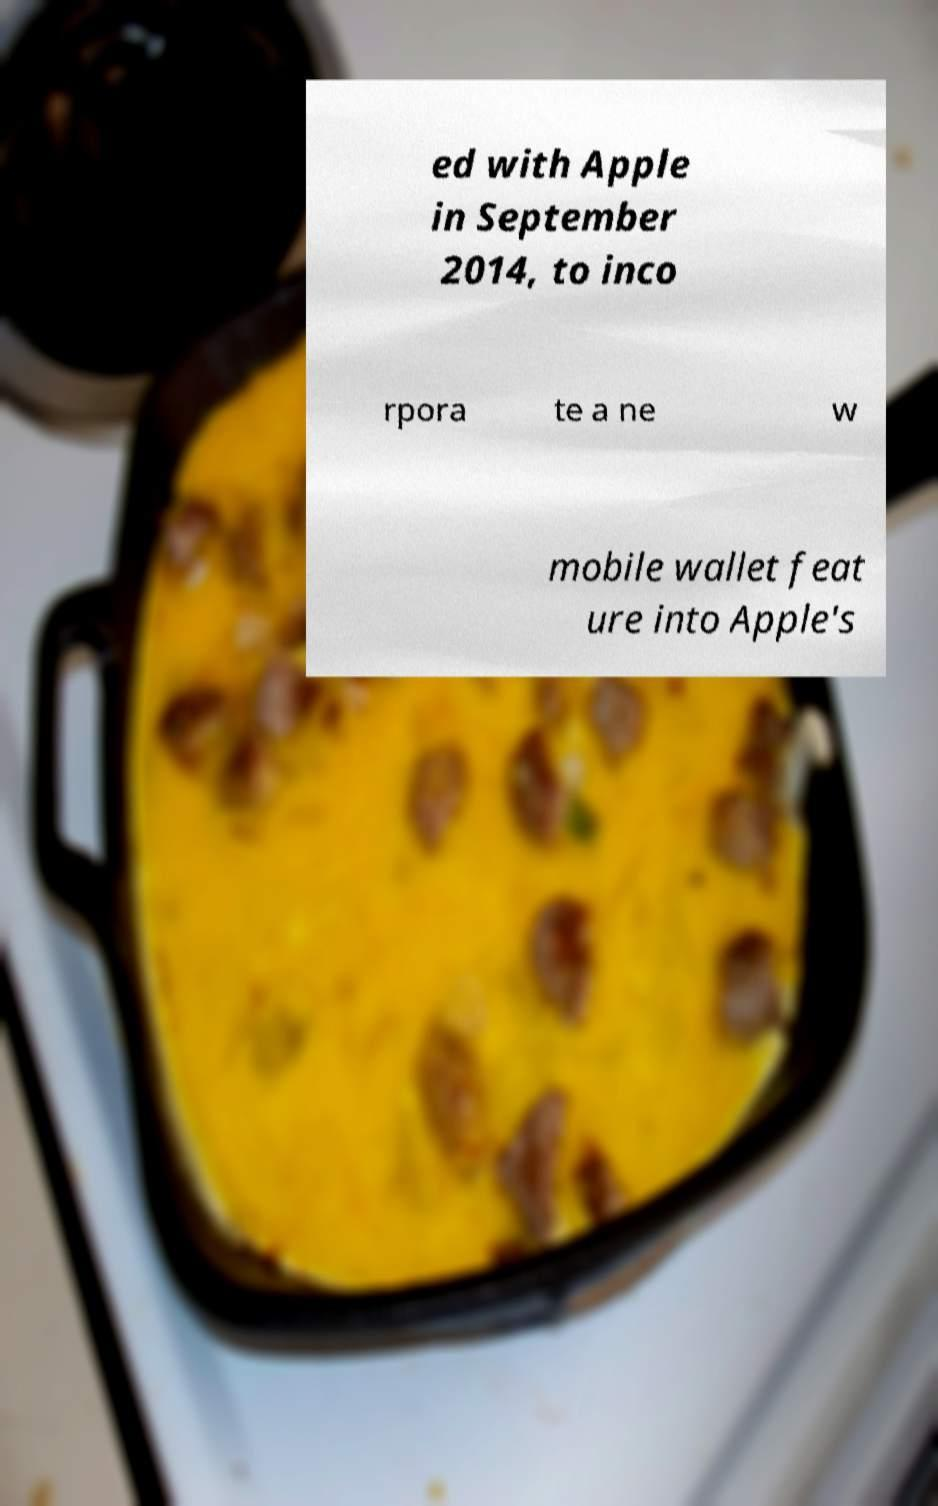Could you assist in decoding the text presented in this image and type it out clearly? ed with Apple in September 2014, to inco rpora te a ne w mobile wallet feat ure into Apple's 